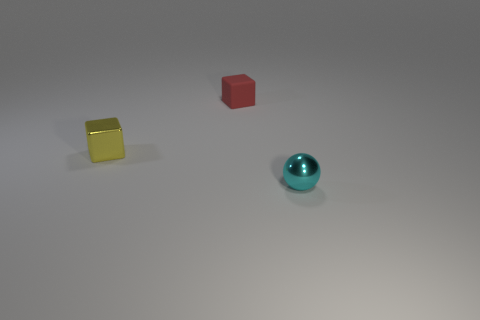There is a rubber cube; does it have the same color as the tiny object right of the small red object?
Make the answer very short. No. Is the small ball the same color as the matte object?
Your answer should be very brief. No. Is the number of small yellow metal objects less than the number of large blue metal objects?
Provide a succinct answer. No. How many small gray rubber things are there?
Offer a terse response. 0. Is the number of cyan objects to the left of the red matte block less than the number of small metallic cubes?
Give a very brief answer. Yes. Is the block that is behind the yellow metal block made of the same material as the tiny sphere?
Provide a succinct answer. No. There is a small metallic thing that is on the left side of the thing behind the tiny metallic thing that is behind the small metal ball; what is its shape?
Ensure brevity in your answer.  Cube. Is there a red block that has the same size as the yellow thing?
Your answer should be very brief. Yes. How big is the red thing?
Ensure brevity in your answer.  Small. How many other yellow cubes have the same size as the yellow metallic block?
Offer a very short reply. 0. 